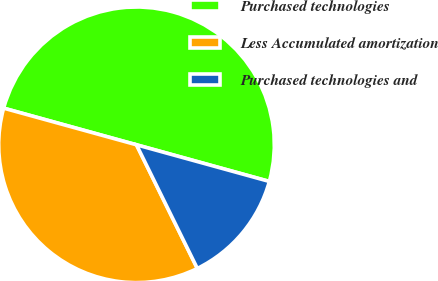<chart> <loc_0><loc_0><loc_500><loc_500><pie_chart><fcel>Purchased technologies<fcel>Less Accumulated amortization<fcel>Purchased technologies and<nl><fcel>50.0%<fcel>36.56%<fcel>13.44%<nl></chart> 